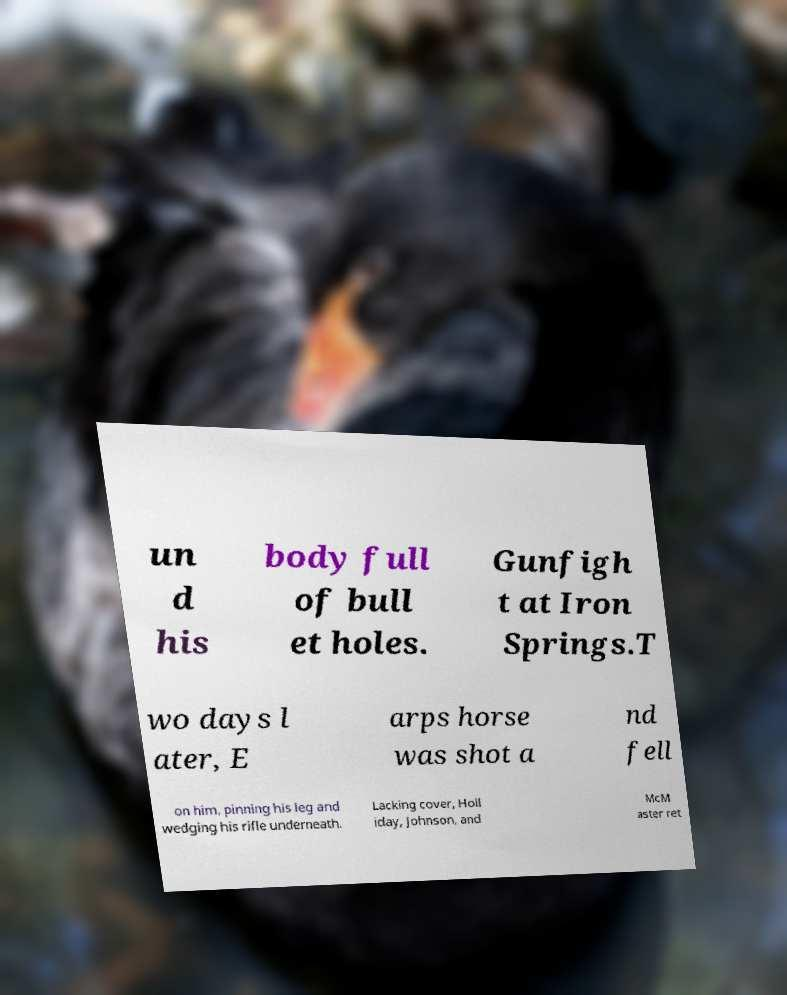What messages or text are displayed in this image? I need them in a readable, typed format. un d his body full of bull et holes. Gunfigh t at Iron Springs.T wo days l ater, E arps horse was shot a nd fell on him, pinning his leg and wedging his rifle underneath. Lacking cover, Holl iday, Johnson, and McM aster ret 